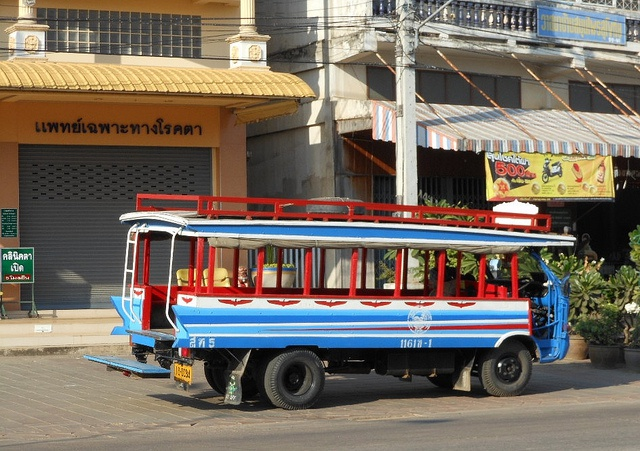Describe the objects in this image and their specific colors. I can see bus in olive, black, white, gray, and brown tones, potted plant in olive, black, and darkgreen tones, potted plant in olive, darkgreen, black, and gray tones, potted plant in olive, black, gray, darkgreen, and beige tones, and potted plant in olive, black, and maroon tones in this image. 